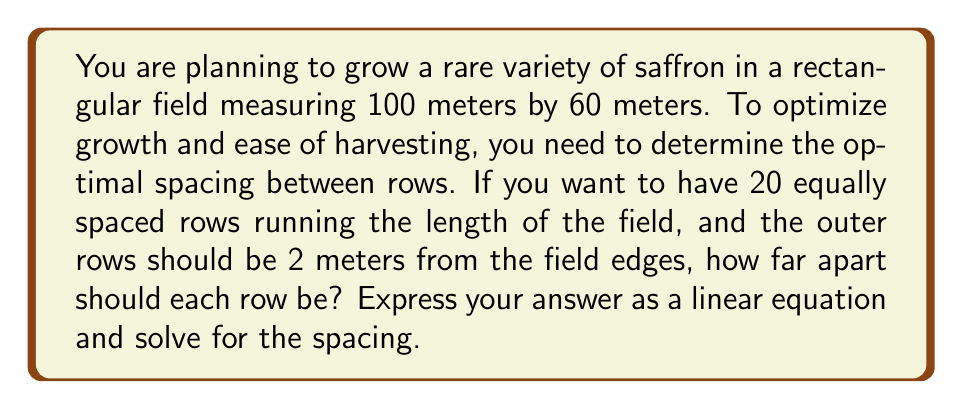Can you solve this math problem? Let's approach this step-by-step:

1) First, we need to set up our variables:
   Let $x$ be the spacing between rows in meters.

2) We know that there are 20 rows, and there are 19 spaces between these rows.

3) The width of the field is 60 meters, and we need to account for the 2-meter buffer on each side:
   Total width available for rows = $60 - 2 - 2 = 56$ meters

4) Now we can set up our linear equation:
   $19x + 20 = 56$

   Here's why:
   - $19x$ represents the total space between rows (19 spaces, each $x$ meters wide)
   - $20$ represents the width taken up by the 20 rows themselves (assuming each row takes up 1 meter)
   - The sum should equal 56, the total available width

5) Solve the equation:
   $19x + 20 = 56$
   $19x = 36$
   $x = \frac{36}{19}$

6) To verify:
   $19 \cdot \frac{36}{19} + 20 = 36 + 20 = 56$

Therefore, the rows should be $\frac{36}{19}$ meters apart (approximately 1.89 meters).
Answer: The optimal spacing between rows can be determined by the linear equation:

$19x + 20 = 56$

Solving this equation gives $x = \frac{36}{19}$ meters (approximately 1.89 meters) between each row. 